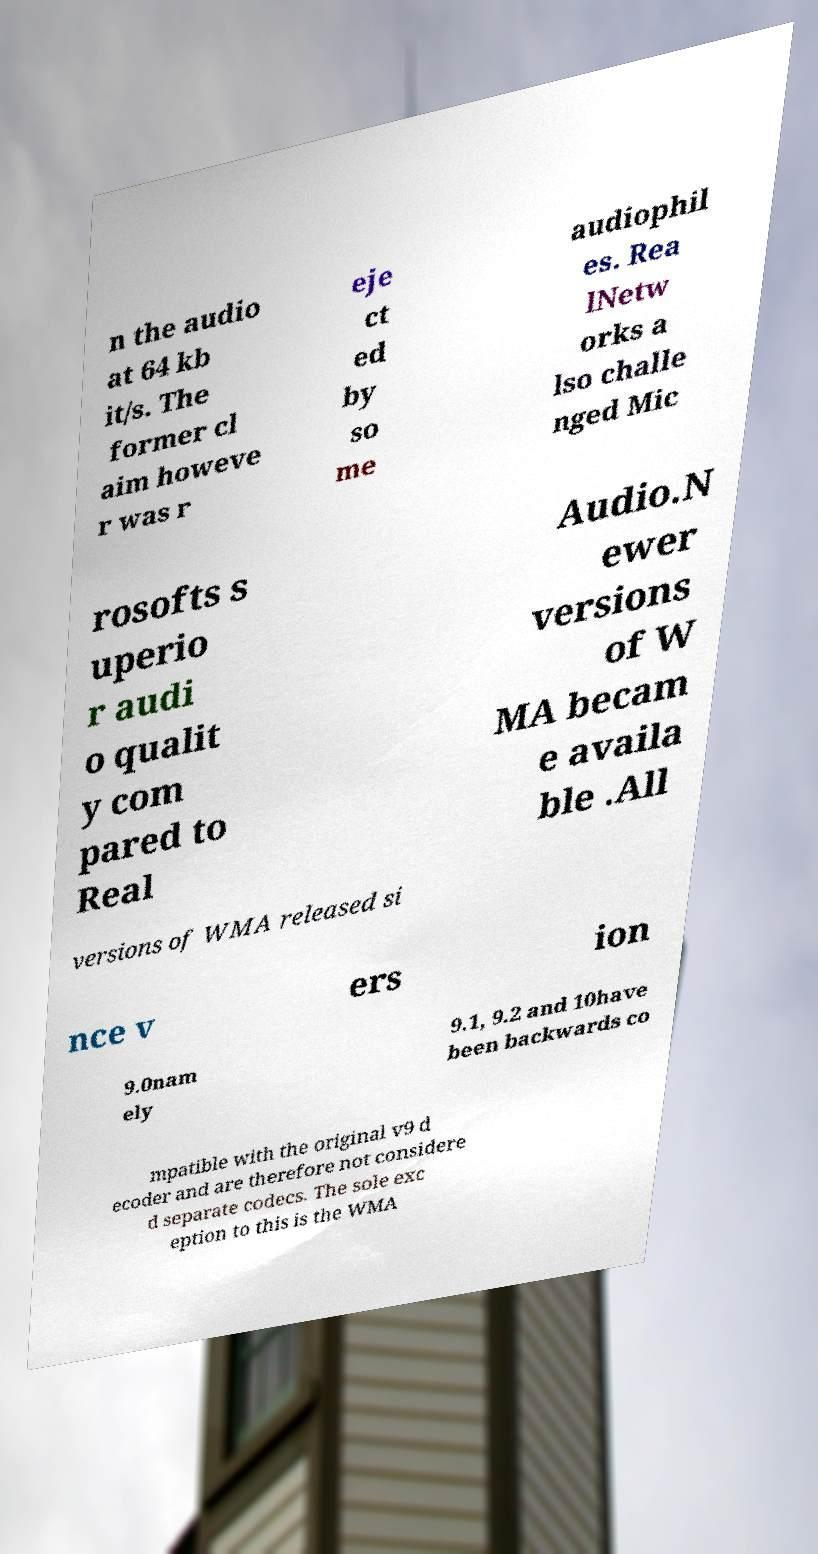For documentation purposes, I need the text within this image transcribed. Could you provide that? n the audio at 64 kb it/s. The former cl aim howeve r was r eje ct ed by so me audiophil es. Rea lNetw orks a lso challe nged Mic rosofts s uperio r audi o qualit y com pared to Real Audio.N ewer versions of W MA becam e availa ble .All versions of WMA released si nce v ers ion 9.0nam ely 9.1, 9.2 and 10have been backwards co mpatible with the original v9 d ecoder and are therefore not considere d separate codecs. The sole exc eption to this is the WMA 